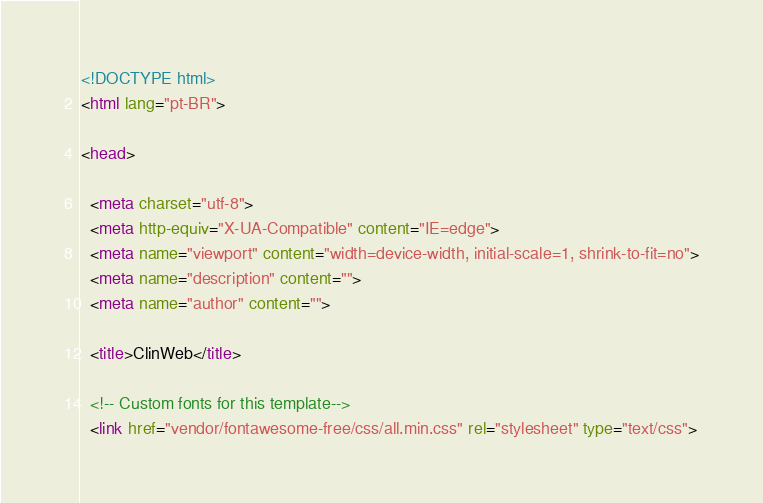<code> <loc_0><loc_0><loc_500><loc_500><_HTML_><!DOCTYPE html>
<html lang="pt-BR">

<head>

  <meta charset="utf-8">
  <meta http-equiv="X-UA-Compatible" content="IE=edge">
  <meta name="viewport" content="width=device-width, initial-scale=1, shrink-to-fit=no">
  <meta name="description" content="">
  <meta name="author" content="">

  <title>ClinWeb</title>

  <!-- Custom fonts for this template-->
  <link href="vendor/fontawesome-free/css/all.min.css" rel="stylesheet" type="text/css"></code> 